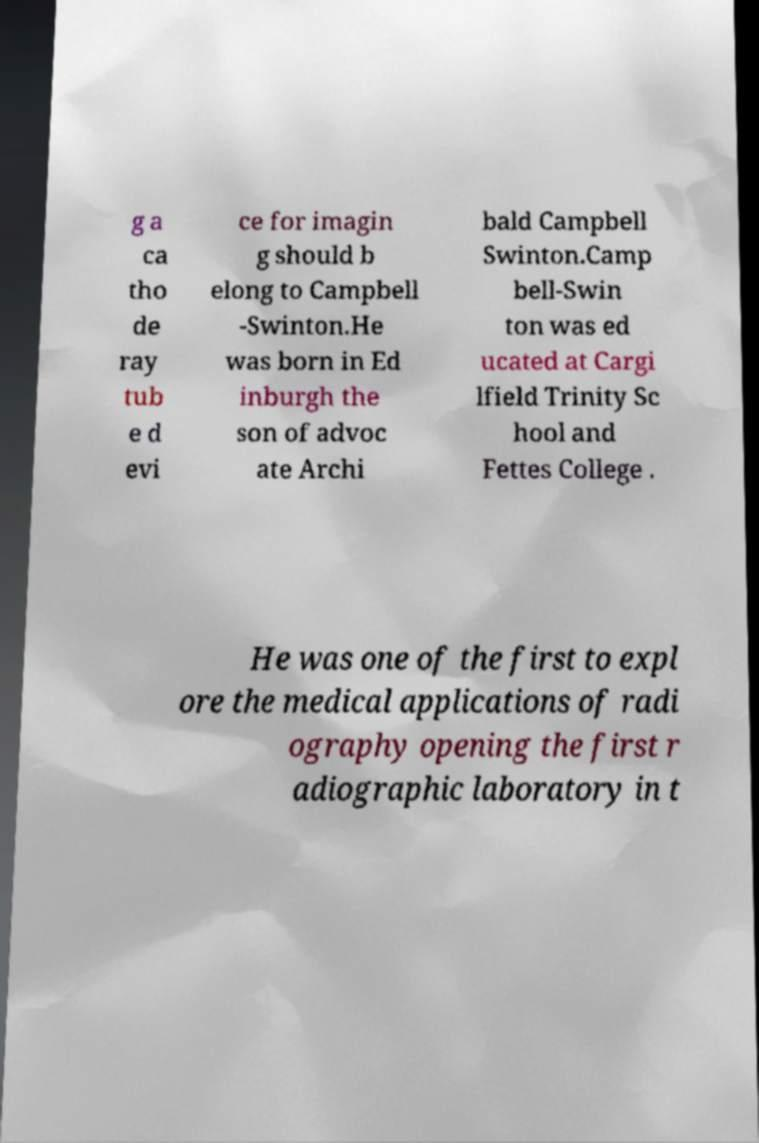Could you extract and type out the text from this image? g a ca tho de ray tub e d evi ce for imagin g should b elong to Campbell -Swinton.He was born in Ed inburgh the son of advoc ate Archi bald Campbell Swinton.Camp bell-Swin ton was ed ucated at Cargi lfield Trinity Sc hool and Fettes College . He was one of the first to expl ore the medical applications of radi ography opening the first r adiographic laboratory in t 